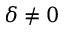Convert formula to latex. <formula><loc_0><loc_0><loc_500><loc_500>\delta \ne 0</formula> 